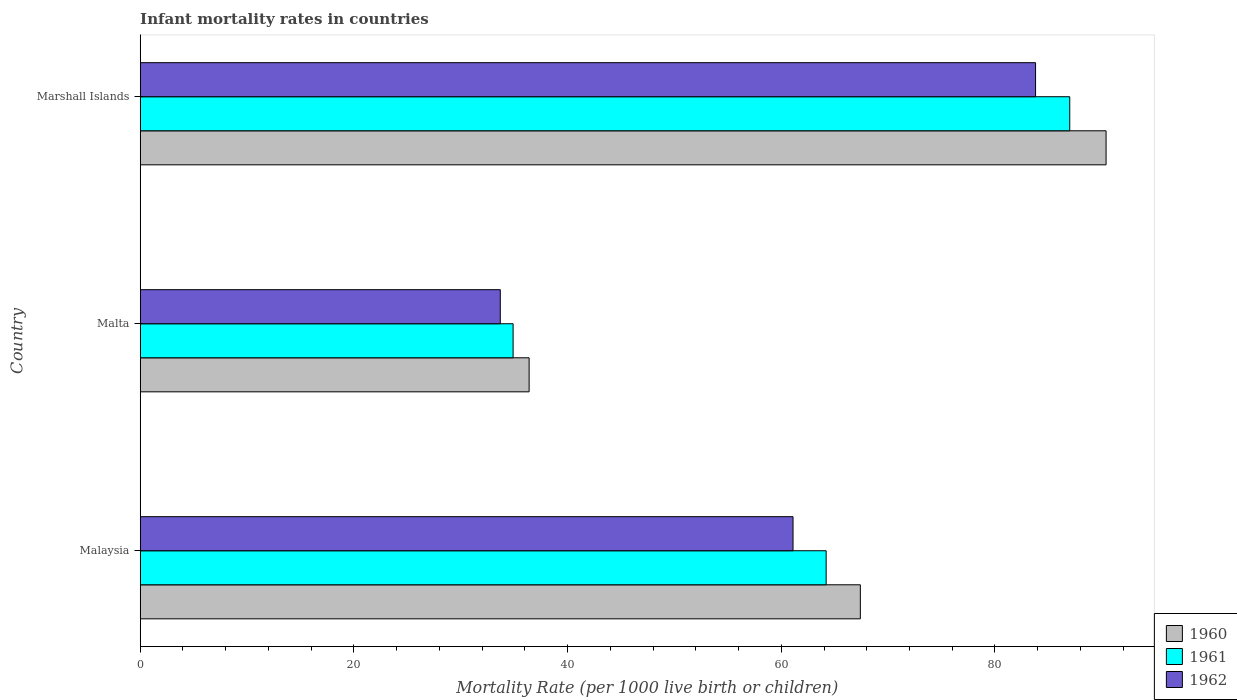Are the number of bars per tick equal to the number of legend labels?
Offer a terse response. Yes. Are the number of bars on each tick of the Y-axis equal?
Keep it short and to the point. Yes. How many bars are there on the 2nd tick from the top?
Provide a short and direct response. 3. What is the label of the 1st group of bars from the top?
Provide a succinct answer. Marshall Islands. In how many cases, is the number of bars for a given country not equal to the number of legend labels?
Offer a terse response. 0. What is the infant mortality rate in 1961 in Malaysia?
Offer a terse response. 64.2. Across all countries, what is the maximum infant mortality rate in 1962?
Your answer should be compact. 83.8. Across all countries, what is the minimum infant mortality rate in 1962?
Give a very brief answer. 33.7. In which country was the infant mortality rate in 1962 maximum?
Offer a terse response. Marshall Islands. In which country was the infant mortality rate in 1962 minimum?
Provide a succinct answer. Malta. What is the total infant mortality rate in 1960 in the graph?
Provide a short and direct response. 194.2. What is the difference between the infant mortality rate in 1962 in Malaysia and that in Malta?
Make the answer very short. 27.4. What is the difference between the infant mortality rate in 1961 in Malaysia and the infant mortality rate in 1962 in Malta?
Your response must be concise. 30.5. What is the average infant mortality rate in 1962 per country?
Provide a succinct answer. 59.53. What is the difference between the infant mortality rate in 1962 and infant mortality rate in 1961 in Marshall Islands?
Your answer should be compact. -3.2. What is the ratio of the infant mortality rate in 1961 in Malaysia to that in Malta?
Offer a terse response. 1.84. Is the infant mortality rate in 1962 in Malaysia less than that in Marshall Islands?
Your response must be concise. Yes. What is the difference between the highest and the second highest infant mortality rate in 1961?
Offer a terse response. 22.8. What is the difference between the highest and the lowest infant mortality rate in 1962?
Offer a very short reply. 50.1. In how many countries, is the infant mortality rate in 1961 greater than the average infant mortality rate in 1961 taken over all countries?
Make the answer very short. 2. Is it the case that in every country, the sum of the infant mortality rate in 1962 and infant mortality rate in 1960 is greater than the infant mortality rate in 1961?
Offer a terse response. Yes. Are all the bars in the graph horizontal?
Provide a succinct answer. Yes. What is the difference between two consecutive major ticks on the X-axis?
Ensure brevity in your answer.  20. Are the values on the major ticks of X-axis written in scientific E-notation?
Make the answer very short. No. Does the graph contain grids?
Your response must be concise. No. How many legend labels are there?
Offer a very short reply. 3. How are the legend labels stacked?
Make the answer very short. Vertical. What is the title of the graph?
Offer a very short reply. Infant mortality rates in countries. What is the label or title of the X-axis?
Keep it short and to the point. Mortality Rate (per 1000 live birth or children). What is the Mortality Rate (per 1000 live birth or children) of 1960 in Malaysia?
Offer a very short reply. 67.4. What is the Mortality Rate (per 1000 live birth or children) in 1961 in Malaysia?
Your answer should be compact. 64.2. What is the Mortality Rate (per 1000 live birth or children) in 1962 in Malaysia?
Your response must be concise. 61.1. What is the Mortality Rate (per 1000 live birth or children) of 1960 in Malta?
Keep it short and to the point. 36.4. What is the Mortality Rate (per 1000 live birth or children) of 1961 in Malta?
Make the answer very short. 34.9. What is the Mortality Rate (per 1000 live birth or children) in 1962 in Malta?
Keep it short and to the point. 33.7. What is the Mortality Rate (per 1000 live birth or children) in 1960 in Marshall Islands?
Provide a short and direct response. 90.4. What is the Mortality Rate (per 1000 live birth or children) of 1961 in Marshall Islands?
Your answer should be very brief. 87. What is the Mortality Rate (per 1000 live birth or children) of 1962 in Marshall Islands?
Offer a very short reply. 83.8. Across all countries, what is the maximum Mortality Rate (per 1000 live birth or children) in 1960?
Provide a succinct answer. 90.4. Across all countries, what is the maximum Mortality Rate (per 1000 live birth or children) of 1962?
Ensure brevity in your answer.  83.8. Across all countries, what is the minimum Mortality Rate (per 1000 live birth or children) in 1960?
Offer a very short reply. 36.4. Across all countries, what is the minimum Mortality Rate (per 1000 live birth or children) of 1961?
Your response must be concise. 34.9. Across all countries, what is the minimum Mortality Rate (per 1000 live birth or children) in 1962?
Your answer should be compact. 33.7. What is the total Mortality Rate (per 1000 live birth or children) of 1960 in the graph?
Make the answer very short. 194.2. What is the total Mortality Rate (per 1000 live birth or children) in 1961 in the graph?
Your answer should be compact. 186.1. What is the total Mortality Rate (per 1000 live birth or children) of 1962 in the graph?
Provide a succinct answer. 178.6. What is the difference between the Mortality Rate (per 1000 live birth or children) of 1960 in Malaysia and that in Malta?
Ensure brevity in your answer.  31. What is the difference between the Mortality Rate (per 1000 live birth or children) of 1961 in Malaysia and that in Malta?
Your answer should be compact. 29.3. What is the difference between the Mortality Rate (per 1000 live birth or children) of 1962 in Malaysia and that in Malta?
Your answer should be compact. 27.4. What is the difference between the Mortality Rate (per 1000 live birth or children) in 1960 in Malaysia and that in Marshall Islands?
Keep it short and to the point. -23. What is the difference between the Mortality Rate (per 1000 live birth or children) in 1961 in Malaysia and that in Marshall Islands?
Your answer should be very brief. -22.8. What is the difference between the Mortality Rate (per 1000 live birth or children) of 1962 in Malaysia and that in Marshall Islands?
Offer a very short reply. -22.7. What is the difference between the Mortality Rate (per 1000 live birth or children) in 1960 in Malta and that in Marshall Islands?
Keep it short and to the point. -54. What is the difference between the Mortality Rate (per 1000 live birth or children) in 1961 in Malta and that in Marshall Islands?
Keep it short and to the point. -52.1. What is the difference between the Mortality Rate (per 1000 live birth or children) in 1962 in Malta and that in Marshall Islands?
Give a very brief answer. -50.1. What is the difference between the Mortality Rate (per 1000 live birth or children) of 1960 in Malaysia and the Mortality Rate (per 1000 live birth or children) of 1961 in Malta?
Ensure brevity in your answer.  32.5. What is the difference between the Mortality Rate (per 1000 live birth or children) in 1960 in Malaysia and the Mortality Rate (per 1000 live birth or children) in 1962 in Malta?
Your answer should be very brief. 33.7. What is the difference between the Mortality Rate (per 1000 live birth or children) of 1961 in Malaysia and the Mortality Rate (per 1000 live birth or children) of 1962 in Malta?
Offer a very short reply. 30.5. What is the difference between the Mortality Rate (per 1000 live birth or children) in 1960 in Malaysia and the Mortality Rate (per 1000 live birth or children) in 1961 in Marshall Islands?
Your answer should be very brief. -19.6. What is the difference between the Mortality Rate (per 1000 live birth or children) in 1960 in Malaysia and the Mortality Rate (per 1000 live birth or children) in 1962 in Marshall Islands?
Make the answer very short. -16.4. What is the difference between the Mortality Rate (per 1000 live birth or children) of 1961 in Malaysia and the Mortality Rate (per 1000 live birth or children) of 1962 in Marshall Islands?
Make the answer very short. -19.6. What is the difference between the Mortality Rate (per 1000 live birth or children) in 1960 in Malta and the Mortality Rate (per 1000 live birth or children) in 1961 in Marshall Islands?
Your response must be concise. -50.6. What is the difference between the Mortality Rate (per 1000 live birth or children) of 1960 in Malta and the Mortality Rate (per 1000 live birth or children) of 1962 in Marshall Islands?
Provide a short and direct response. -47.4. What is the difference between the Mortality Rate (per 1000 live birth or children) in 1961 in Malta and the Mortality Rate (per 1000 live birth or children) in 1962 in Marshall Islands?
Provide a short and direct response. -48.9. What is the average Mortality Rate (per 1000 live birth or children) in 1960 per country?
Ensure brevity in your answer.  64.73. What is the average Mortality Rate (per 1000 live birth or children) of 1961 per country?
Provide a succinct answer. 62.03. What is the average Mortality Rate (per 1000 live birth or children) of 1962 per country?
Keep it short and to the point. 59.53. What is the difference between the Mortality Rate (per 1000 live birth or children) in 1961 and Mortality Rate (per 1000 live birth or children) in 1962 in Malaysia?
Your answer should be very brief. 3.1. What is the difference between the Mortality Rate (per 1000 live birth or children) in 1960 and Mortality Rate (per 1000 live birth or children) in 1961 in Malta?
Your answer should be compact. 1.5. What is the difference between the Mortality Rate (per 1000 live birth or children) in 1961 and Mortality Rate (per 1000 live birth or children) in 1962 in Malta?
Your answer should be compact. 1.2. What is the difference between the Mortality Rate (per 1000 live birth or children) in 1961 and Mortality Rate (per 1000 live birth or children) in 1962 in Marshall Islands?
Provide a short and direct response. 3.2. What is the ratio of the Mortality Rate (per 1000 live birth or children) in 1960 in Malaysia to that in Malta?
Your answer should be compact. 1.85. What is the ratio of the Mortality Rate (per 1000 live birth or children) in 1961 in Malaysia to that in Malta?
Your response must be concise. 1.84. What is the ratio of the Mortality Rate (per 1000 live birth or children) in 1962 in Malaysia to that in Malta?
Your answer should be compact. 1.81. What is the ratio of the Mortality Rate (per 1000 live birth or children) in 1960 in Malaysia to that in Marshall Islands?
Your answer should be very brief. 0.75. What is the ratio of the Mortality Rate (per 1000 live birth or children) in 1961 in Malaysia to that in Marshall Islands?
Give a very brief answer. 0.74. What is the ratio of the Mortality Rate (per 1000 live birth or children) in 1962 in Malaysia to that in Marshall Islands?
Offer a very short reply. 0.73. What is the ratio of the Mortality Rate (per 1000 live birth or children) in 1960 in Malta to that in Marshall Islands?
Offer a very short reply. 0.4. What is the ratio of the Mortality Rate (per 1000 live birth or children) in 1961 in Malta to that in Marshall Islands?
Provide a short and direct response. 0.4. What is the ratio of the Mortality Rate (per 1000 live birth or children) in 1962 in Malta to that in Marshall Islands?
Your answer should be very brief. 0.4. What is the difference between the highest and the second highest Mortality Rate (per 1000 live birth or children) in 1961?
Make the answer very short. 22.8. What is the difference between the highest and the second highest Mortality Rate (per 1000 live birth or children) in 1962?
Offer a terse response. 22.7. What is the difference between the highest and the lowest Mortality Rate (per 1000 live birth or children) in 1961?
Provide a short and direct response. 52.1. What is the difference between the highest and the lowest Mortality Rate (per 1000 live birth or children) in 1962?
Your answer should be compact. 50.1. 